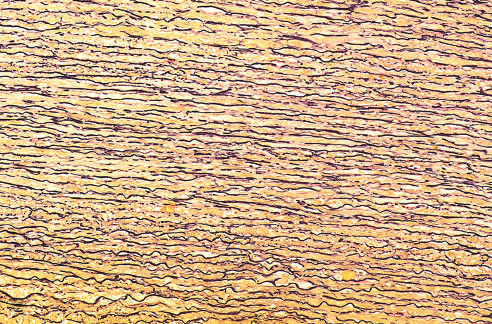what did the normal media show of elastic tissue?
Answer the question using a single word or phrase. Regular layered pattern of elastic tissue 